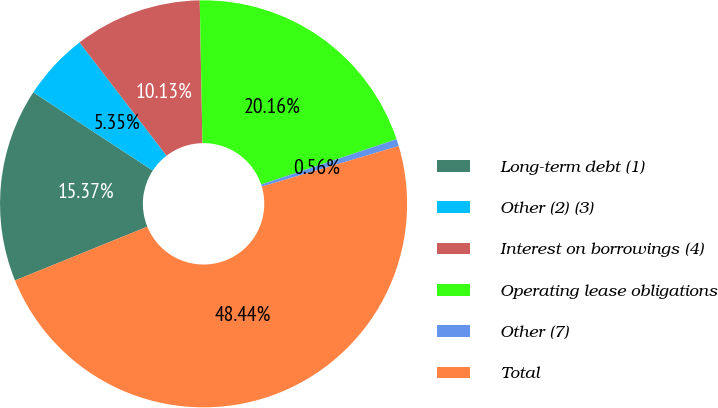Convert chart. <chart><loc_0><loc_0><loc_500><loc_500><pie_chart><fcel>Long-term debt (1)<fcel>Other (2) (3)<fcel>Interest on borrowings (4)<fcel>Operating lease obligations<fcel>Other (7)<fcel>Total<nl><fcel>15.37%<fcel>5.35%<fcel>10.13%<fcel>20.16%<fcel>0.56%<fcel>48.44%<nl></chart> 